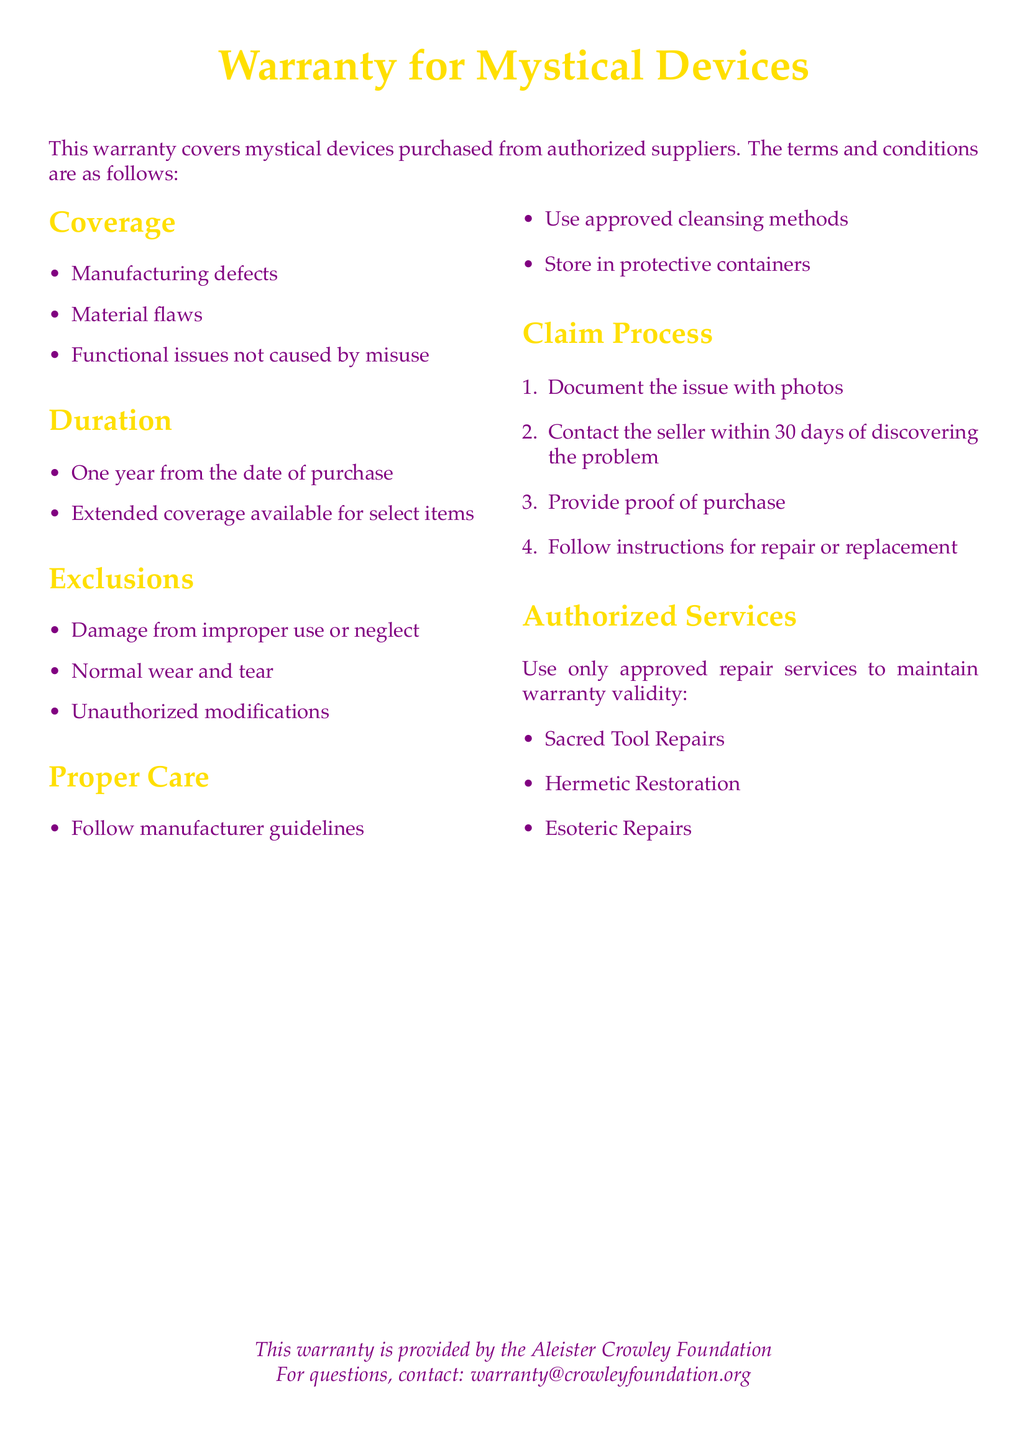What does the warranty cover? The warranty covers manufacturing defects, material flaws, and functional issues not caused by misuse.
Answer: manufacturing defects, material flaws, functional issues not caused by misuse How long is the warranty duration? The warranty duration is specified as one year from the date of purchase.
Answer: One year What are the exclusions of the warranty? Exclusions include damage from improper use or neglect, normal wear and tear, and unauthorized modifications.
Answer: damage from improper use or neglect, normal wear and tear, unauthorized modifications What must you do within 30 days of discovering a problem? You must contact the seller within 30 days of discovering the problem to maintain warranty coverage.
Answer: contact the seller Name a service that is authorized for repairs. An authorized repair service mentioned in the document is Sacred Tool Repairs.
Answer: Sacred Tool Repairs What is required for making a claim? You must provide proof of purchase as part of the claim process.
Answer: proof of purchase How long can you extend the coverage? The document states that extended coverage is available for select items, but does not specify an exact duration.
Answer: select items Who provides this warranty? The warranty is provided by the Aleister Crowley Foundation.
Answer: Aleister Crowley Foundation 